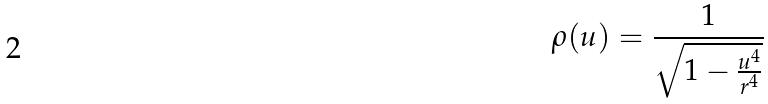Convert formula to latex. <formula><loc_0><loc_0><loc_500><loc_500>\rho ( u ) = \frac { 1 } { \sqrt { 1 - \frac { u ^ { 4 } } { r ^ { 4 } } } }</formula> 